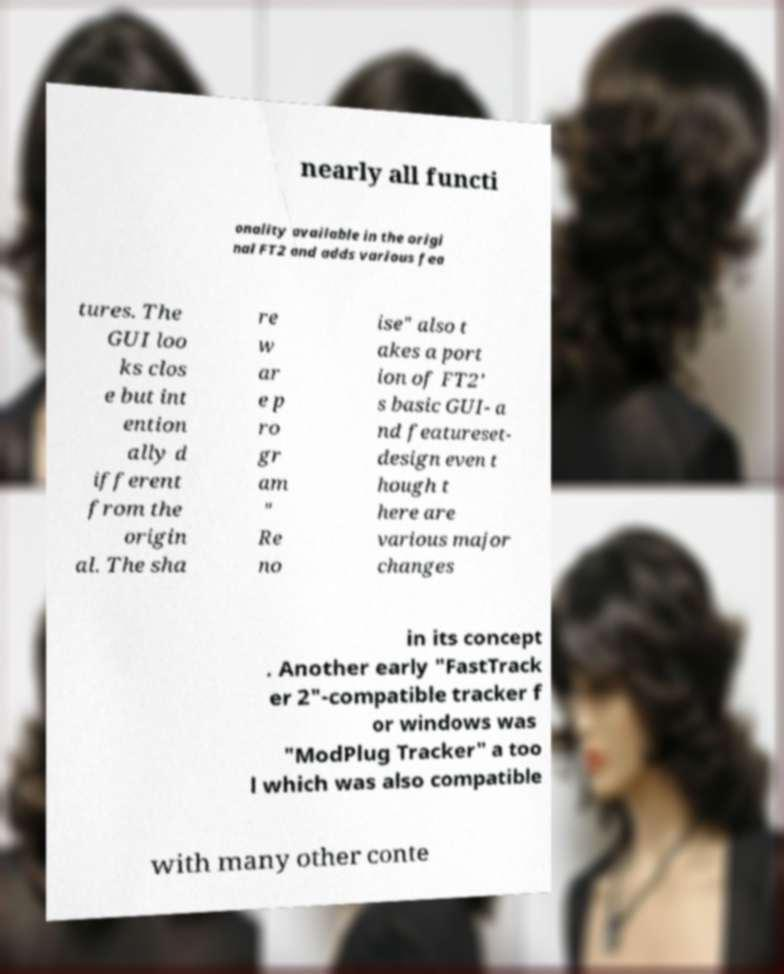I need the written content from this picture converted into text. Can you do that? nearly all functi onality available in the origi nal FT2 and adds various fea tures. The GUI loo ks clos e but int ention ally d ifferent from the origin al. The sha re w ar e p ro gr am " Re no ise" also t akes a port ion of FT2' s basic GUI- a nd featureset- design even t hough t here are various major changes in its concept . Another early "FastTrack er 2"-compatible tracker f or windows was "ModPlug Tracker" a too l which was also compatible with many other conte 